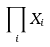<formula> <loc_0><loc_0><loc_500><loc_500>\prod _ { i } X _ { i }</formula> 